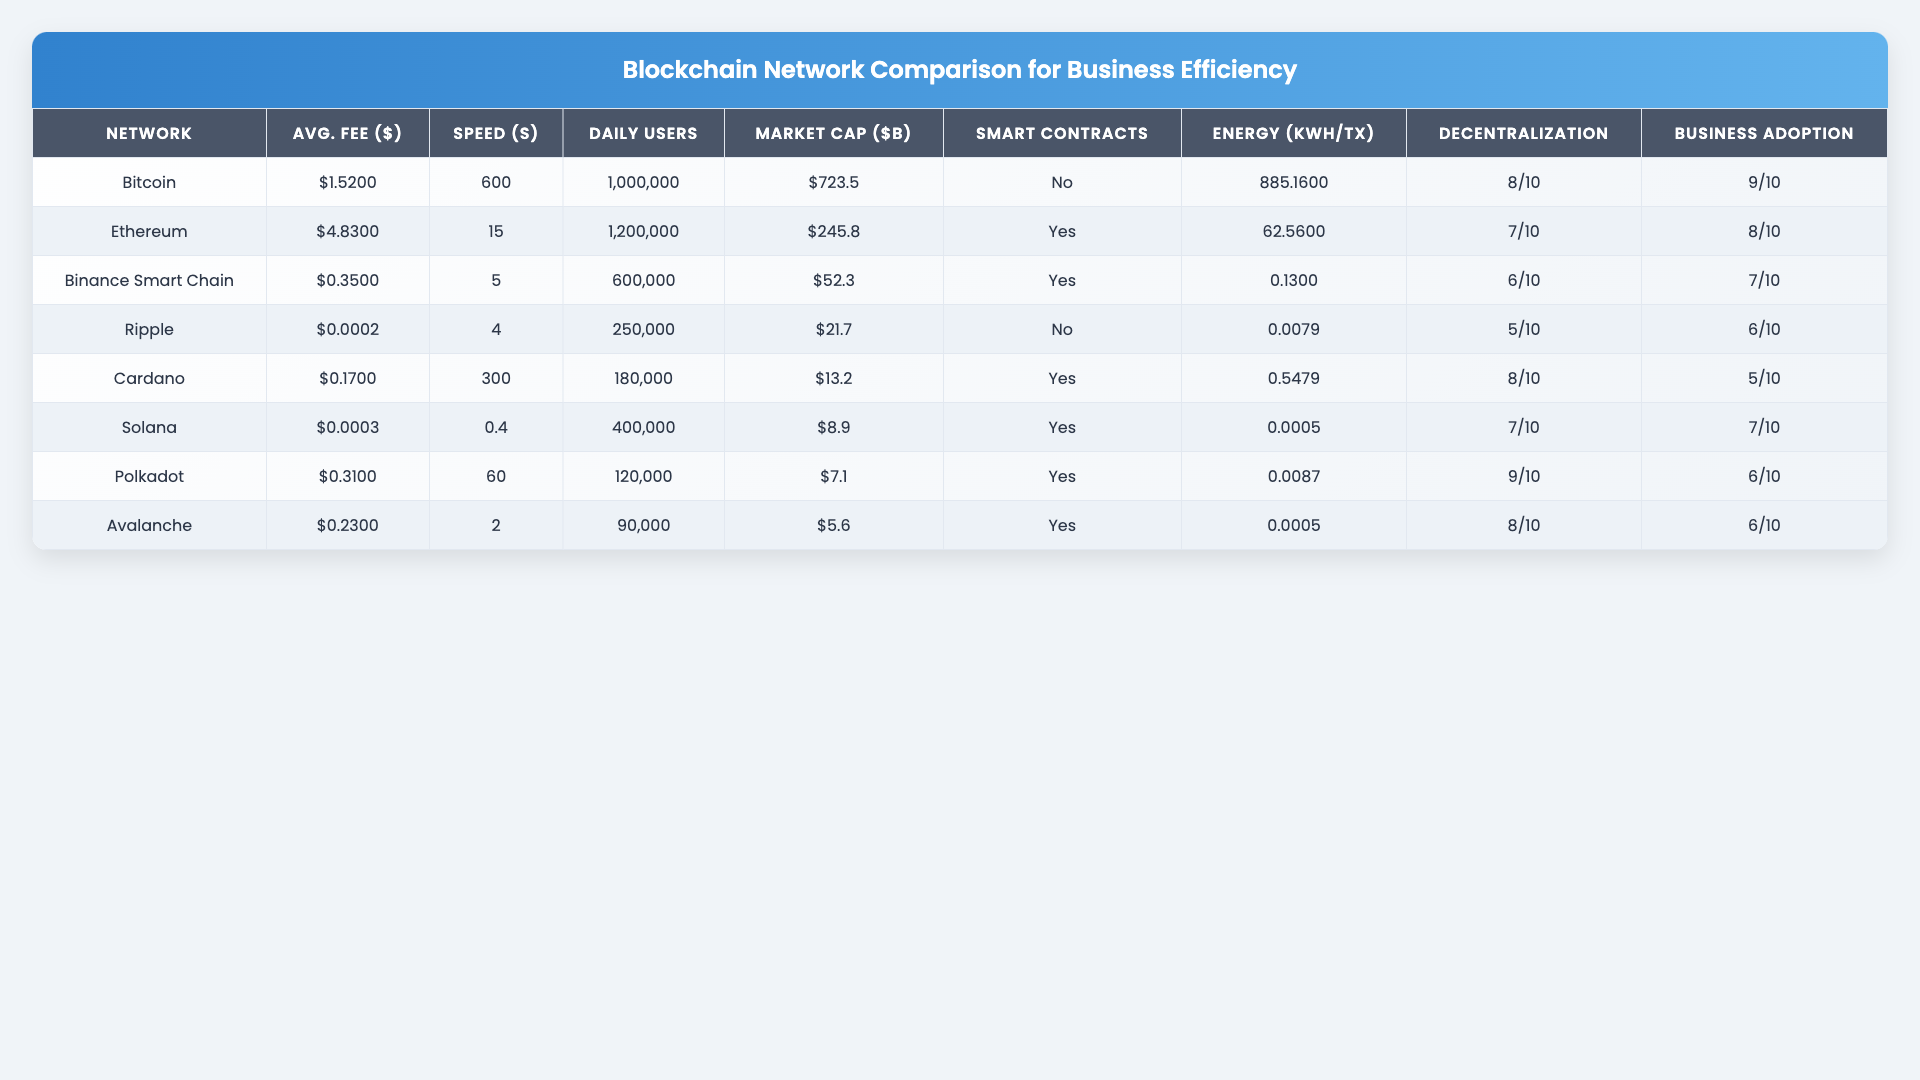What is the average transaction fee for Solana? The table shows that the average transaction fee for Solana is $0.00025.
Answer: $0.00025 Which blockchain network has the highest market cap? The table indicates that Bitcoin has the highest market cap at $723.5 billion.
Answer: Bitcoin How long does it take to confirm a transaction on Ethereum? According to the table, it takes 15 seconds to confirm a transaction on Ethereum.
Answer: 15 seconds How many daily active users does Cardano have? The table states that Cardano has 180,000 daily active users.
Answer: 180,000 Which blockchain network supports smart contracts? The table shows that Ethereum, Binance Smart Chain, Cardano, Solana, Polkadot, Avalanche support smart contracts, while Bitcoin and Ripple do not.
Answer: Yes What is the difference between the average transaction fees of Bitcoin and Binance Smart Chain? The average transaction fee for Bitcoin is $1.52, and for Binance Smart Chain, it is $0.35. The difference is $1.52 - $0.35 = $1.17.
Answer: $1.17 Which blockchain has the lowest energy consumption per transaction? The table indicates that Solana has the lowest energy consumption per transaction at 0.00051 kWh.
Answer: Solana What is the decentralization score of Polkadot? The table shows that Polkadot has a decentralization score of 9 out of 10.
Answer: 9/10 Which blockchain network has the fastest transaction speed? According to the table, Solana has the fastest transaction speed at 0.4 seconds.
Answer: 0.4 seconds If we calculate the average transaction fee for all networks, what is the result? Adding the transaction fees: (1.52 + 4.83 + 0.35 + 0.0002 + 0.17 + 0.00025 + 0.31 + 0.23) = 7.62. Dividing by the number of networks (8), the average is 7.62/8 = 0.9525.
Answer: $0.9525 How many blockchain networks support smart contracts? The table shows that six networks (Ethereum, Binance Smart Chain, Cardano, Solana, Polkadot, Avalanche) support smart contracts.
Answer: 6 What is the average transaction speed across Binance Smart Chain and Ripple? The transaction speed for Binance Smart Chain is 5 seconds and for Ripple is 4 seconds. The average is (5 + 4)/2 = 4.5 seconds.
Answer: 4.5 seconds What is the market cap of Avalanche? From the table, Avalanche has a market cap of $5.6 billion.
Answer: $5.6 billion Does any blockchain network have a business adoption score of 10? The table indicates that no blockchain network has a business adoption score of 10; the highest is 9 for Bitcoin.
Answer: No 